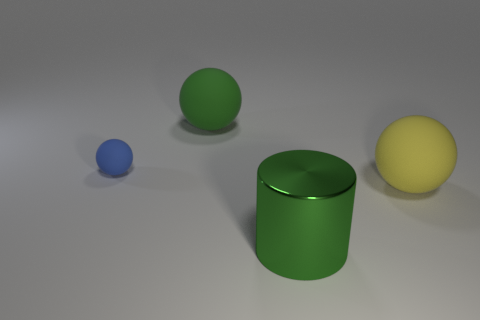Add 3 large rubber things. How many objects exist? 7 Subtract all balls. How many objects are left? 1 Add 2 yellow balls. How many yellow balls are left? 3 Add 4 green blocks. How many green blocks exist? 4 Subtract 0 yellow blocks. How many objects are left? 4 Subtract all small yellow spheres. Subtract all spheres. How many objects are left? 1 